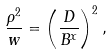<formula> <loc_0><loc_0><loc_500><loc_500>\frac { \rho ^ { 2 } } { w } = \left ( \frac { D } { B ^ { x } } \right ) ^ { 2 } ,</formula> 